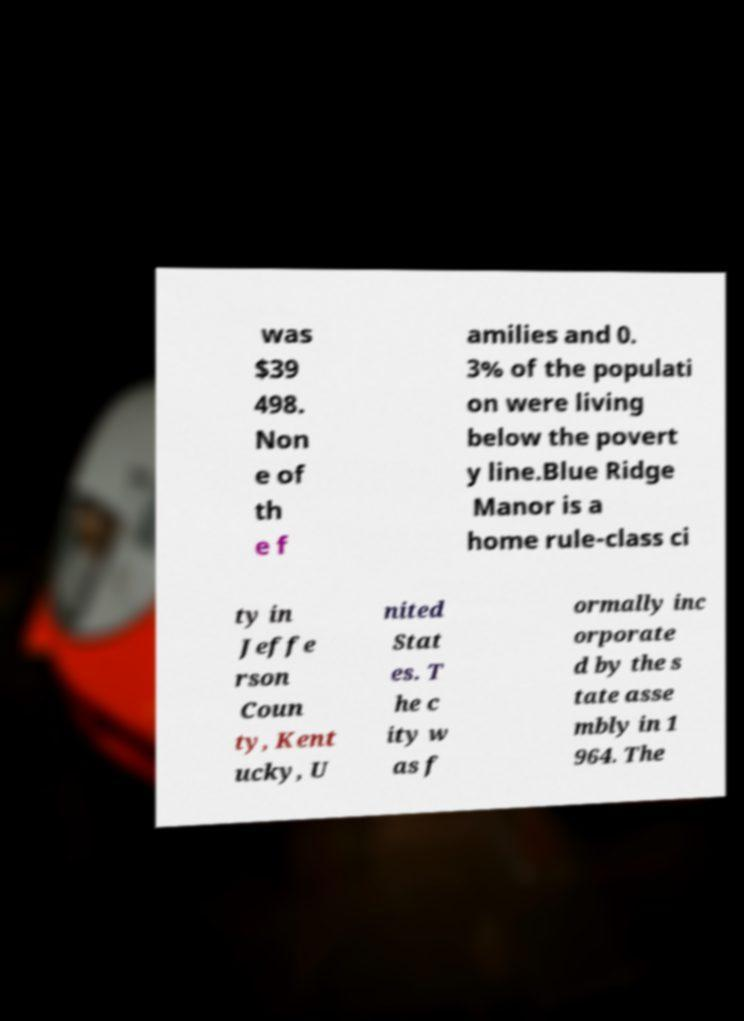There's text embedded in this image that I need extracted. Can you transcribe it verbatim? was $39 498. Non e of th e f amilies and 0. 3% of the populati on were living below the povert y line.Blue Ridge Manor is a home rule-class ci ty in Jeffe rson Coun ty, Kent ucky, U nited Stat es. T he c ity w as f ormally inc orporate d by the s tate asse mbly in 1 964. The 